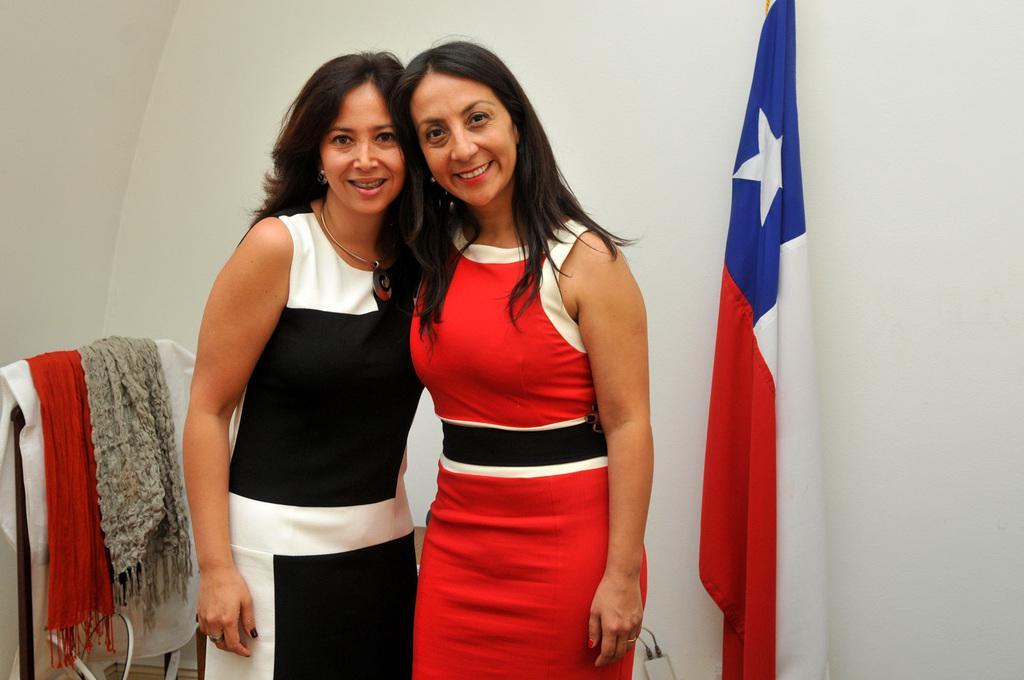Describe this image in one or two sentences. In this image there are two women standing. To the right there is a flag. To the left there are scarfs on the stand. Behind them there is a wall. 